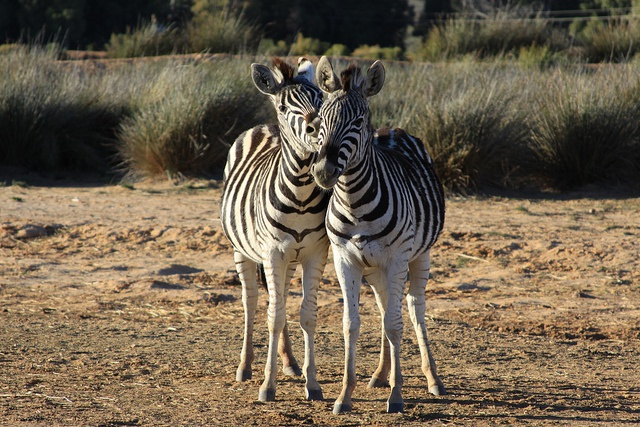Describe the objects in this image and their specific colors. I can see zebra in black, gray, beige, and tan tones and zebra in black, gray, and beige tones in this image. 